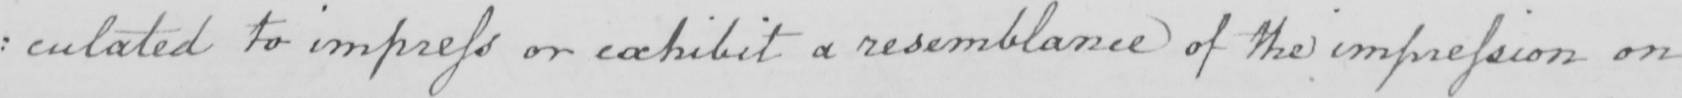What text is written in this handwritten line? : culated to impress or exhibit a resemblance of the impression on 